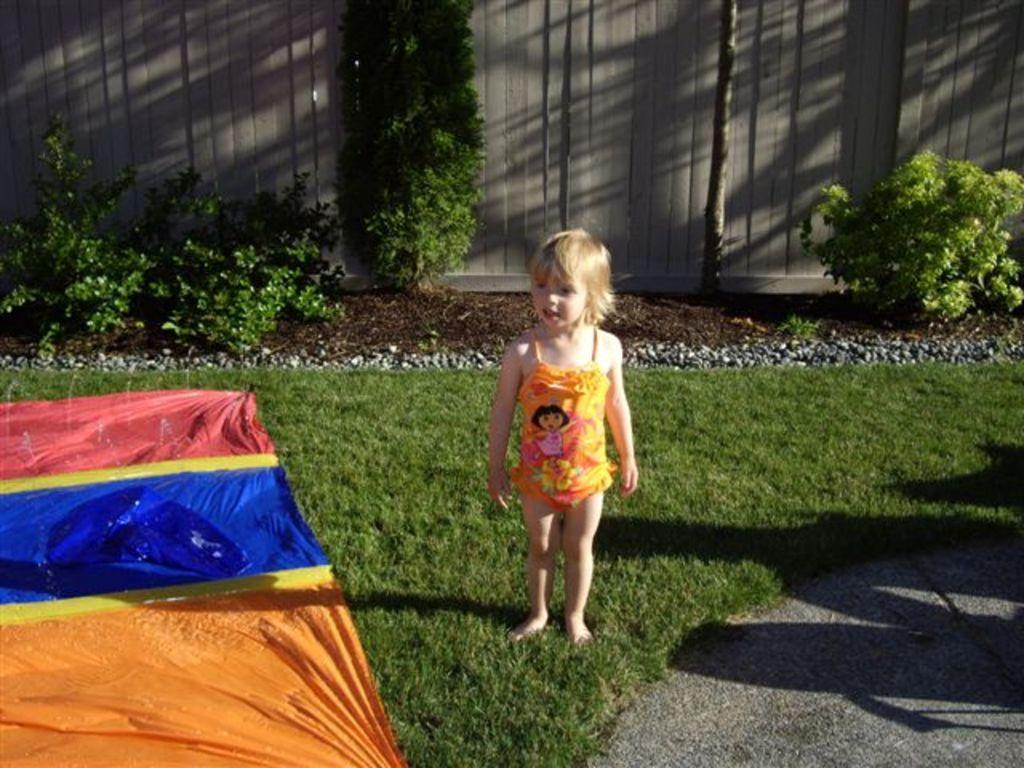Please provide a concise description of this image. This is a small girl standing. I think these are the colorful waterproof tarps, which are on the grass. I can see a tree and the small bushes. In the background, that looks like a wooden fence. These are the small rocks. At the bottom right side of the image, that looks like a pathway. 